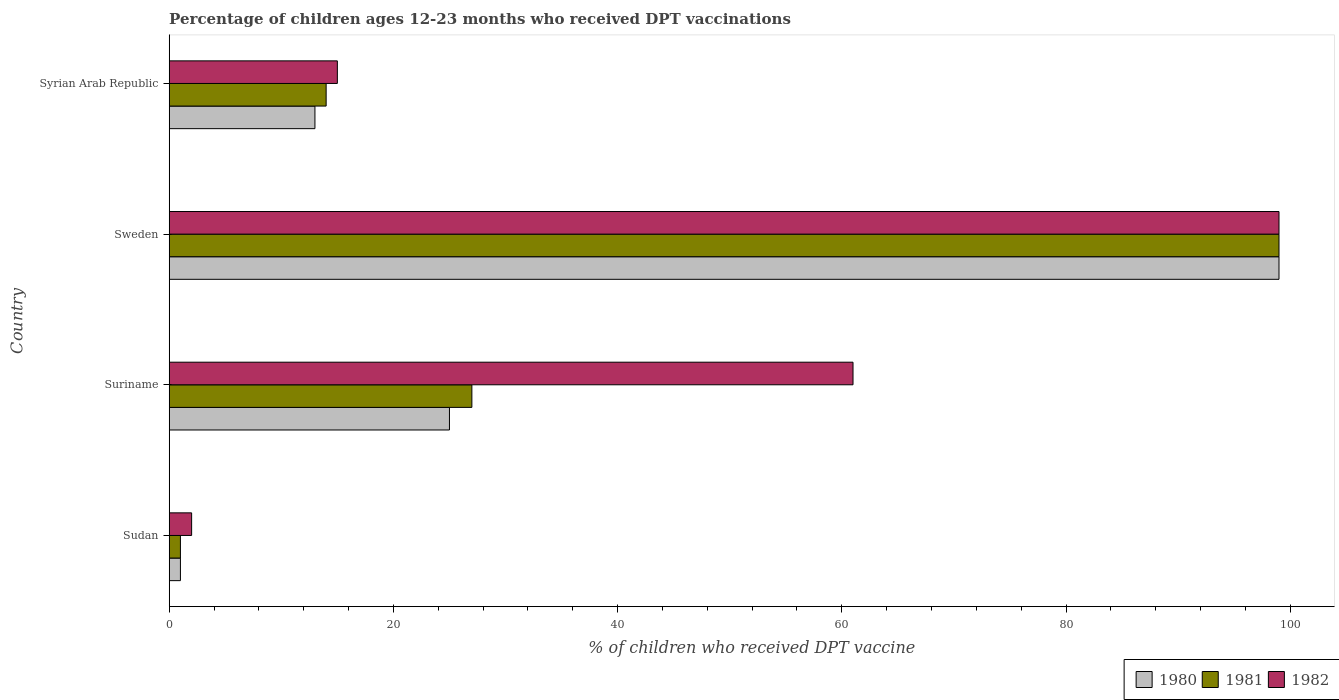Are the number of bars on each tick of the Y-axis equal?
Keep it short and to the point. Yes. How many bars are there on the 2nd tick from the top?
Ensure brevity in your answer.  3. What is the label of the 4th group of bars from the top?
Give a very brief answer. Sudan. In how many cases, is the number of bars for a given country not equal to the number of legend labels?
Offer a very short reply. 0. In which country was the percentage of children who received DPT vaccination in 1980 maximum?
Offer a very short reply. Sweden. In which country was the percentage of children who received DPT vaccination in 1980 minimum?
Make the answer very short. Sudan. What is the total percentage of children who received DPT vaccination in 1981 in the graph?
Offer a very short reply. 141. What is the difference between the percentage of children who received DPT vaccination in 1980 in Suriname and that in Sweden?
Your answer should be very brief. -74. What is the difference between the percentage of children who received DPT vaccination in 1980 in Syrian Arab Republic and the percentage of children who received DPT vaccination in 1982 in Sweden?
Keep it short and to the point. -86. What is the average percentage of children who received DPT vaccination in 1980 per country?
Keep it short and to the point. 34.5. What is the difference between the percentage of children who received DPT vaccination in 1980 and percentage of children who received DPT vaccination in 1981 in Sweden?
Provide a succinct answer. 0. In how many countries, is the percentage of children who received DPT vaccination in 1981 greater than 68 %?
Provide a short and direct response. 1. Is the difference between the percentage of children who received DPT vaccination in 1980 in Sudan and Sweden greater than the difference between the percentage of children who received DPT vaccination in 1981 in Sudan and Sweden?
Provide a short and direct response. No. What is the difference between the highest and the lowest percentage of children who received DPT vaccination in 1982?
Offer a terse response. 97. In how many countries, is the percentage of children who received DPT vaccination in 1980 greater than the average percentage of children who received DPT vaccination in 1980 taken over all countries?
Offer a very short reply. 1. Is it the case that in every country, the sum of the percentage of children who received DPT vaccination in 1981 and percentage of children who received DPT vaccination in 1980 is greater than the percentage of children who received DPT vaccination in 1982?
Make the answer very short. No. How many bars are there?
Your answer should be very brief. 12. Are the values on the major ticks of X-axis written in scientific E-notation?
Keep it short and to the point. No. Does the graph contain grids?
Make the answer very short. No. What is the title of the graph?
Ensure brevity in your answer.  Percentage of children ages 12-23 months who received DPT vaccinations. Does "1995" appear as one of the legend labels in the graph?
Provide a succinct answer. No. What is the label or title of the X-axis?
Your response must be concise. % of children who received DPT vaccine. What is the % of children who received DPT vaccine in 1981 in Sudan?
Your answer should be very brief. 1. What is the % of children who received DPT vaccine in 1980 in Suriname?
Your answer should be very brief. 25. What is the % of children who received DPT vaccine of 1980 in Sweden?
Give a very brief answer. 99. What is the % of children who received DPT vaccine in 1980 in Syrian Arab Republic?
Provide a short and direct response. 13. Across all countries, what is the maximum % of children who received DPT vaccine in 1980?
Your answer should be compact. 99. Across all countries, what is the maximum % of children who received DPT vaccine in 1981?
Provide a succinct answer. 99. Across all countries, what is the maximum % of children who received DPT vaccine of 1982?
Give a very brief answer. 99. Across all countries, what is the minimum % of children who received DPT vaccine in 1980?
Offer a very short reply. 1. Across all countries, what is the minimum % of children who received DPT vaccine of 1982?
Provide a succinct answer. 2. What is the total % of children who received DPT vaccine in 1980 in the graph?
Give a very brief answer. 138. What is the total % of children who received DPT vaccine in 1981 in the graph?
Your response must be concise. 141. What is the total % of children who received DPT vaccine in 1982 in the graph?
Your response must be concise. 177. What is the difference between the % of children who received DPT vaccine of 1980 in Sudan and that in Suriname?
Give a very brief answer. -24. What is the difference between the % of children who received DPT vaccine in 1981 in Sudan and that in Suriname?
Make the answer very short. -26. What is the difference between the % of children who received DPT vaccine of 1982 in Sudan and that in Suriname?
Offer a terse response. -59. What is the difference between the % of children who received DPT vaccine in 1980 in Sudan and that in Sweden?
Provide a succinct answer. -98. What is the difference between the % of children who received DPT vaccine in 1981 in Sudan and that in Sweden?
Provide a short and direct response. -98. What is the difference between the % of children who received DPT vaccine of 1982 in Sudan and that in Sweden?
Give a very brief answer. -97. What is the difference between the % of children who received DPT vaccine in 1980 in Sudan and that in Syrian Arab Republic?
Offer a very short reply. -12. What is the difference between the % of children who received DPT vaccine of 1982 in Sudan and that in Syrian Arab Republic?
Offer a very short reply. -13. What is the difference between the % of children who received DPT vaccine in 1980 in Suriname and that in Sweden?
Provide a succinct answer. -74. What is the difference between the % of children who received DPT vaccine of 1981 in Suriname and that in Sweden?
Give a very brief answer. -72. What is the difference between the % of children who received DPT vaccine in 1982 in Suriname and that in Sweden?
Your answer should be very brief. -38. What is the difference between the % of children who received DPT vaccine of 1982 in Sweden and that in Syrian Arab Republic?
Offer a terse response. 84. What is the difference between the % of children who received DPT vaccine in 1980 in Sudan and the % of children who received DPT vaccine in 1981 in Suriname?
Your answer should be very brief. -26. What is the difference between the % of children who received DPT vaccine in 1980 in Sudan and the % of children who received DPT vaccine in 1982 in Suriname?
Provide a succinct answer. -60. What is the difference between the % of children who received DPT vaccine in 1981 in Sudan and the % of children who received DPT vaccine in 1982 in Suriname?
Your answer should be very brief. -60. What is the difference between the % of children who received DPT vaccine of 1980 in Sudan and the % of children who received DPT vaccine of 1981 in Sweden?
Your answer should be compact. -98. What is the difference between the % of children who received DPT vaccine in 1980 in Sudan and the % of children who received DPT vaccine in 1982 in Sweden?
Offer a very short reply. -98. What is the difference between the % of children who received DPT vaccine in 1981 in Sudan and the % of children who received DPT vaccine in 1982 in Sweden?
Provide a short and direct response. -98. What is the difference between the % of children who received DPT vaccine of 1980 in Sudan and the % of children who received DPT vaccine of 1982 in Syrian Arab Republic?
Your response must be concise. -14. What is the difference between the % of children who received DPT vaccine in 1981 in Sudan and the % of children who received DPT vaccine in 1982 in Syrian Arab Republic?
Provide a succinct answer. -14. What is the difference between the % of children who received DPT vaccine of 1980 in Suriname and the % of children who received DPT vaccine of 1981 in Sweden?
Your answer should be compact. -74. What is the difference between the % of children who received DPT vaccine in 1980 in Suriname and the % of children who received DPT vaccine in 1982 in Sweden?
Provide a short and direct response. -74. What is the difference between the % of children who received DPT vaccine of 1981 in Suriname and the % of children who received DPT vaccine of 1982 in Sweden?
Make the answer very short. -72. What is the difference between the % of children who received DPT vaccine of 1980 in Suriname and the % of children who received DPT vaccine of 1981 in Syrian Arab Republic?
Provide a short and direct response. 11. What is the difference between the % of children who received DPT vaccine of 1980 in Suriname and the % of children who received DPT vaccine of 1982 in Syrian Arab Republic?
Offer a terse response. 10. What is the difference between the % of children who received DPT vaccine in 1980 in Sweden and the % of children who received DPT vaccine in 1981 in Syrian Arab Republic?
Provide a short and direct response. 85. What is the difference between the % of children who received DPT vaccine in 1980 in Sweden and the % of children who received DPT vaccine in 1982 in Syrian Arab Republic?
Your response must be concise. 84. What is the difference between the % of children who received DPT vaccine of 1981 in Sweden and the % of children who received DPT vaccine of 1982 in Syrian Arab Republic?
Ensure brevity in your answer.  84. What is the average % of children who received DPT vaccine of 1980 per country?
Keep it short and to the point. 34.5. What is the average % of children who received DPT vaccine of 1981 per country?
Offer a terse response. 35.25. What is the average % of children who received DPT vaccine in 1982 per country?
Provide a short and direct response. 44.25. What is the difference between the % of children who received DPT vaccine of 1981 and % of children who received DPT vaccine of 1982 in Sudan?
Your answer should be compact. -1. What is the difference between the % of children who received DPT vaccine in 1980 and % of children who received DPT vaccine in 1981 in Suriname?
Give a very brief answer. -2. What is the difference between the % of children who received DPT vaccine of 1980 and % of children who received DPT vaccine of 1982 in Suriname?
Your response must be concise. -36. What is the difference between the % of children who received DPT vaccine of 1981 and % of children who received DPT vaccine of 1982 in Suriname?
Give a very brief answer. -34. What is the difference between the % of children who received DPT vaccine in 1980 and % of children who received DPT vaccine in 1981 in Sweden?
Provide a short and direct response. 0. What is the difference between the % of children who received DPT vaccine in 1980 and % of children who received DPT vaccine in 1982 in Sweden?
Your answer should be very brief. 0. What is the difference between the % of children who received DPT vaccine of 1981 and % of children who received DPT vaccine of 1982 in Sweden?
Make the answer very short. 0. What is the difference between the % of children who received DPT vaccine in 1980 and % of children who received DPT vaccine in 1981 in Syrian Arab Republic?
Provide a short and direct response. -1. What is the difference between the % of children who received DPT vaccine of 1980 and % of children who received DPT vaccine of 1982 in Syrian Arab Republic?
Offer a terse response. -2. What is the ratio of the % of children who received DPT vaccine in 1981 in Sudan to that in Suriname?
Give a very brief answer. 0.04. What is the ratio of the % of children who received DPT vaccine in 1982 in Sudan to that in Suriname?
Provide a succinct answer. 0.03. What is the ratio of the % of children who received DPT vaccine in 1980 in Sudan to that in Sweden?
Make the answer very short. 0.01. What is the ratio of the % of children who received DPT vaccine in 1981 in Sudan to that in Sweden?
Provide a short and direct response. 0.01. What is the ratio of the % of children who received DPT vaccine of 1982 in Sudan to that in Sweden?
Provide a short and direct response. 0.02. What is the ratio of the % of children who received DPT vaccine of 1980 in Sudan to that in Syrian Arab Republic?
Make the answer very short. 0.08. What is the ratio of the % of children who received DPT vaccine of 1981 in Sudan to that in Syrian Arab Republic?
Ensure brevity in your answer.  0.07. What is the ratio of the % of children who received DPT vaccine in 1982 in Sudan to that in Syrian Arab Republic?
Ensure brevity in your answer.  0.13. What is the ratio of the % of children who received DPT vaccine in 1980 in Suriname to that in Sweden?
Your answer should be compact. 0.25. What is the ratio of the % of children who received DPT vaccine in 1981 in Suriname to that in Sweden?
Your response must be concise. 0.27. What is the ratio of the % of children who received DPT vaccine in 1982 in Suriname to that in Sweden?
Your response must be concise. 0.62. What is the ratio of the % of children who received DPT vaccine in 1980 in Suriname to that in Syrian Arab Republic?
Offer a very short reply. 1.92. What is the ratio of the % of children who received DPT vaccine of 1981 in Suriname to that in Syrian Arab Republic?
Keep it short and to the point. 1.93. What is the ratio of the % of children who received DPT vaccine in 1982 in Suriname to that in Syrian Arab Republic?
Offer a terse response. 4.07. What is the ratio of the % of children who received DPT vaccine of 1980 in Sweden to that in Syrian Arab Republic?
Your answer should be very brief. 7.62. What is the ratio of the % of children who received DPT vaccine of 1981 in Sweden to that in Syrian Arab Republic?
Your response must be concise. 7.07. What is the difference between the highest and the lowest % of children who received DPT vaccine in 1980?
Offer a terse response. 98. What is the difference between the highest and the lowest % of children who received DPT vaccine in 1982?
Offer a very short reply. 97. 